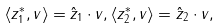<formula> <loc_0><loc_0><loc_500><loc_500>\langle z _ { 1 } ^ { * } , v \rangle = \hat { z } _ { 1 } \cdot v , \langle z _ { 2 } ^ { * } , v \rangle = \hat { z } _ { 2 } \cdot v ,</formula> 